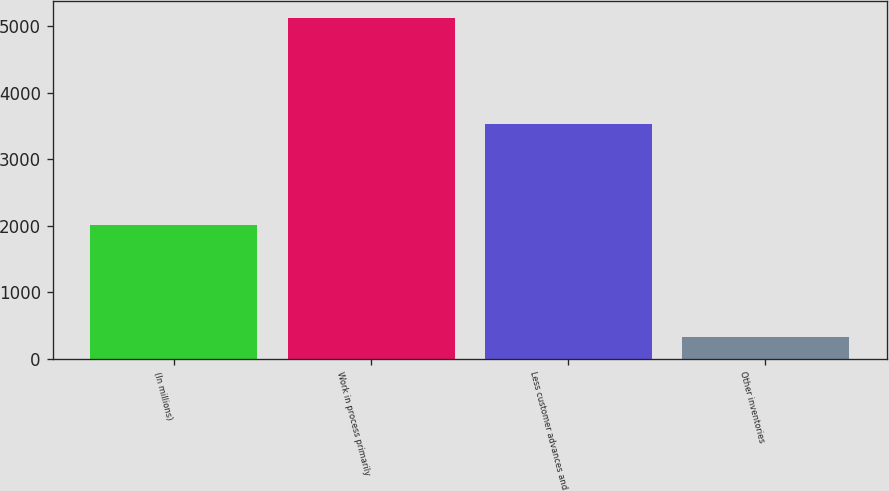Convert chart. <chart><loc_0><loc_0><loc_500><loc_500><bar_chart><fcel>(In millions)<fcel>Work in process primarily<fcel>Less customer advances and<fcel>Other inventories<nl><fcel>2005<fcel>5121<fcel>3527<fcel>327<nl></chart> 